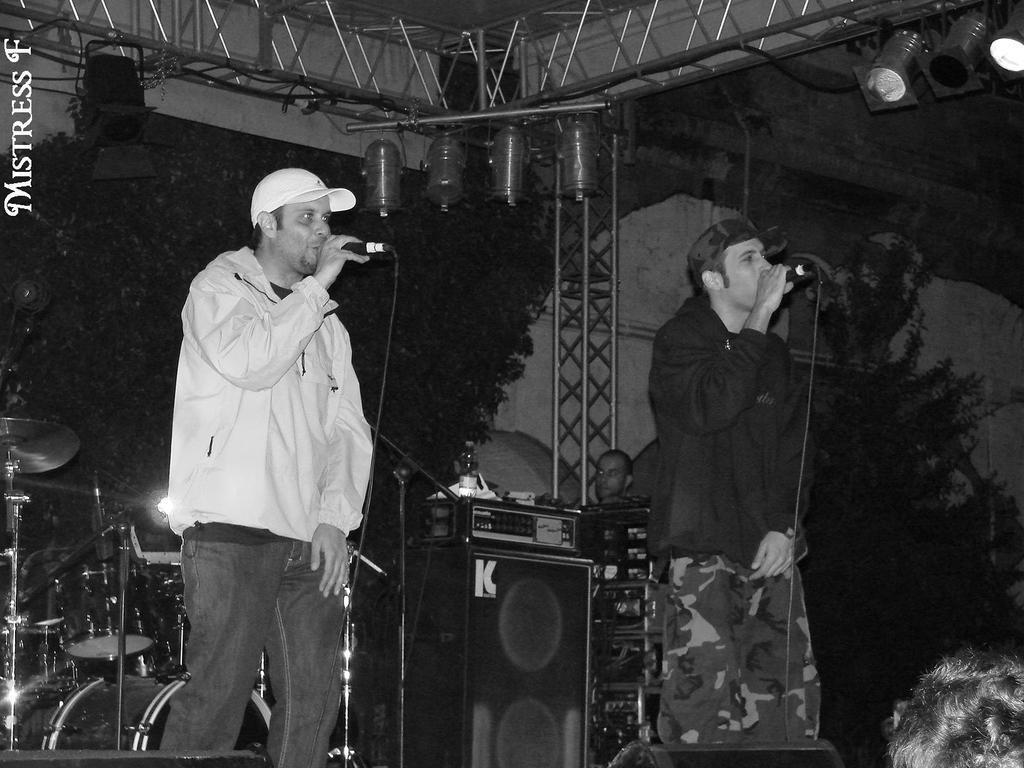How would you summarize this image in a sentence or two? This is a black and white image, and here we can see people standing and holding mics, one of them is wearing a cap. In the background, there are musical instruments and we can see a person, trees and rods. At the top, there are lights and there is roof and we can see some text. 